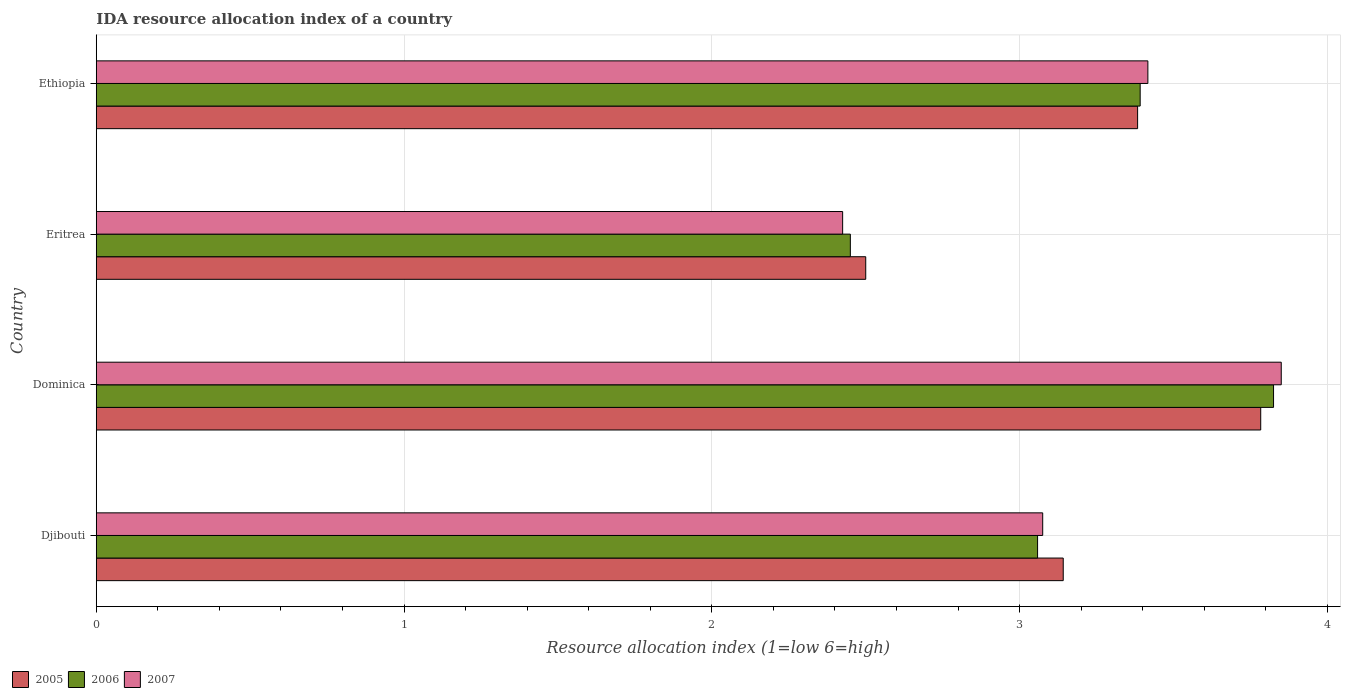Are the number of bars per tick equal to the number of legend labels?
Provide a short and direct response. Yes. How many bars are there on the 3rd tick from the bottom?
Your answer should be compact. 3. What is the label of the 2nd group of bars from the top?
Make the answer very short. Eritrea. In how many cases, is the number of bars for a given country not equal to the number of legend labels?
Provide a succinct answer. 0. What is the IDA resource allocation index in 2006 in Djibouti?
Provide a short and direct response. 3.06. Across all countries, what is the maximum IDA resource allocation index in 2007?
Offer a very short reply. 3.85. Across all countries, what is the minimum IDA resource allocation index in 2007?
Make the answer very short. 2.42. In which country was the IDA resource allocation index in 2007 maximum?
Ensure brevity in your answer.  Dominica. In which country was the IDA resource allocation index in 2006 minimum?
Make the answer very short. Eritrea. What is the total IDA resource allocation index in 2006 in the graph?
Provide a succinct answer. 12.73. What is the difference between the IDA resource allocation index in 2005 in Djibouti and that in Ethiopia?
Offer a very short reply. -0.24. What is the difference between the IDA resource allocation index in 2005 in Dominica and the IDA resource allocation index in 2007 in Ethiopia?
Keep it short and to the point. 0.37. What is the average IDA resource allocation index in 2005 per country?
Ensure brevity in your answer.  3.2. What is the difference between the IDA resource allocation index in 2007 and IDA resource allocation index in 2006 in Djibouti?
Offer a terse response. 0.02. In how many countries, is the IDA resource allocation index in 2005 greater than 0.6000000000000001 ?
Keep it short and to the point. 4. What is the ratio of the IDA resource allocation index in 2006 in Eritrea to that in Ethiopia?
Offer a very short reply. 0.72. Is the IDA resource allocation index in 2007 in Djibouti less than that in Dominica?
Ensure brevity in your answer.  Yes. Is the difference between the IDA resource allocation index in 2007 in Dominica and Ethiopia greater than the difference between the IDA resource allocation index in 2006 in Dominica and Ethiopia?
Your response must be concise. No. What is the difference between the highest and the second highest IDA resource allocation index in 2007?
Give a very brief answer. 0.43. What is the difference between the highest and the lowest IDA resource allocation index in 2007?
Ensure brevity in your answer.  1.43. Is the sum of the IDA resource allocation index in 2007 in Eritrea and Ethiopia greater than the maximum IDA resource allocation index in 2005 across all countries?
Give a very brief answer. Yes. What is the difference between two consecutive major ticks on the X-axis?
Make the answer very short. 1. Does the graph contain any zero values?
Offer a very short reply. No. What is the title of the graph?
Your answer should be compact. IDA resource allocation index of a country. What is the label or title of the X-axis?
Your response must be concise. Resource allocation index (1=low 6=high). What is the Resource allocation index (1=low 6=high) of 2005 in Djibouti?
Make the answer very short. 3.14. What is the Resource allocation index (1=low 6=high) in 2006 in Djibouti?
Your response must be concise. 3.06. What is the Resource allocation index (1=low 6=high) in 2007 in Djibouti?
Give a very brief answer. 3.08. What is the Resource allocation index (1=low 6=high) in 2005 in Dominica?
Offer a terse response. 3.78. What is the Resource allocation index (1=low 6=high) in 2006 in Dominica?
Your answer should be very brief. 3.83. What is the Resource allocation index (1=low 6=high) in 2007 in Dominica?
Ensure brevity in your answer.  3.85. What is the Resource allocation index (1=low 6=high) of 2005 in Eritrea?
Give a very brief answer. 2.5. What is the Resource allocation index (1=low 6=high) in 2006 in Eritrea?
Provide a short and direct response. 2.45. What is the Resource allocation index (1=low 6=high) in 2007 in Eritrea?
Your answer should be compact. 2.42. What is the Resource allocation index (1=low 6=high) of 2005 in Ethiopia?
Offer a terse response. 3.38. What is the Resource allocation index (1=low 6=high) in 2006 in Ethiopia?
Provide a short and direct response. 3.39. What is the Resource allocation index (1=low 6=high) in 2007 in Ethiopia?
Provide a succinct answer. 3.42. Across all countries, what is the maximum Resource allocation index (1=low 6=high) of 2005?
Your answer should be compact. 3.78. Across all countries, what is the maximum Resource allocation index (1=low 6=high) in 2006?
Your answer should be compact. 3.83. Across all countries, what is the maximum Resource allocation index (1=low 6=high) of 2007?
Your answer should be very brief. 3.85. Across all countries, what is the minimum Resource allocation index (1=low 6=high) of 2006?
Your answer should be very brief. 2.45. Across all countries, what is the minimum Resource allocation index (1=low 6=high) of 2007?
Your answer should be compact. 2.42. What is the total Resource allocation index (1=low 6=high) in 2005 in the graph?
Your response must be concise. 12.81. What is the total Resource allocation index (1=low 6=high) of 2006 in the graph?
Give a very brief answer. 12.72. What is the total Resource allocation index (1=low 6=high) of 2007 in the graph?
Offer a very short reply. 12.77. What is the difference between the Resource allocation index (1=low 6=high) of 2005 in Djibouti and that in Dominica?
Your response must be concise. -0.64. What is the difference between the Resource allocation index (1=low 6=high) of 2006 in Djibouti and that in Dominica?
Your response must be concise. -0.77. What is the difference between the Resource allocation index (1=low 6=high) of 2007 in Djibouti and that in Dominica?
Your answer should be compact. -0.78. What is the difference between the Resource allocation index (1=low 6=high) of 2005 in Djibouti and that in Eritrea?
Keep it short and to the point. 0.64. What is the difference between the Resource allocation index (1=low 6=high) in 2006 in Djibouti and that in Eritrea?
Ensure brevity in your answer.  0.61. What is the difference between the Resource allocation index (1=low 6=high) of 2007 in Djibouti and that in Eritrea?
Offer a terse response. 0.65. What is the difference between the Resource allocation index (1=low 6=high) of 2005 in Djibouti and that in Ethiopia?
Your response must be concise. -0.24. What is the difference between the Resource allocation index (1=low 6=high) of 2006 in Djibouti and that in Ethiopia?
Provide a short and direct response. -0.33. What is the difference between the Resource allocation index (1=low 6=high) of 2007 in Djibouti and that in Ethiopia?
Offer a terse response. -0.34. What is the difference between the Resource allocation index (1=low 6=high) in 2005 in Dominica and that in Eritrea?
Give a very brief answer. 1.28. What is the difference between the Resource allocation index (1=low 6=high) of 2006 in Dominica and that in Eritrea?
Keep it short and to the point. 1.38. What is the difference between the Resource allocation index (1=low 6=high) of 2007 in Dominica and that in Eritrea?
Your answer should be compact. 1.43. What is the difference between the Resource allocation index (1=low 6=high) of 2005 in Dominica and that in Ethiopia?
Provide a succinct answer. 0.4. What is the difference between the Resource allocation index (1=low 6=high) in 2006 in Dominica and that in Ethiopia?
Provide a short and direct response. 0.43. What is the difference between the Resource allocation index (1=low 6=high) of 2007 in Dominica and that in Ethiopia?
Provide a succinct answer. 0.43. What is the difference between the Resource allocation index (1=low 6=high) of 2005 in Eritrea and that in Ethiopia?
Provide a succinct answer. -0.88. What is the difference between the Resource allocation index (1=low 6=high) in 2006 in Eritrea and that in Ethiopia?
Your response must be concise. -0.94. What is the difference between the Resource allocation index (1=low 6=high) in 2007 in Eritrea and that in Ethiopia?
Give a very brief answer. -0.99. What is the difference between the Resource allocation index (1=low 6=high) in 2005 in Djibouti and the Resource allocation index (1=low 6=high) in 2006 in Dominica?
Give a very brief answer. -0.68. What is the difference between the Resource allocation index (1=low 6=high) in 2005 in Djibouti and the Resource allocation index (1=low 6=high) in 2007 in Dominica?
Provide a succinct answer. -0.71. What is the difference between the Resource allocation index (1=low 6=high) in 2006 in Djibouti and the Resource allocation index (1=low 6=high) in 2007 in Dominica?
Offer a very short reply. -0.79. What is the difference between the Resource allocation index (1=low 6=high) in 2005 in Djibouti and the Resource allocation index (1=low 6=high) in 2006 in Eritrea?
Make the answer very short. 0.69. What is the difference between the Resource allocation index (1=low 6=high) of 2005 in Djibouti and the Resource allocation index (1=low 6=high) of 2007 in Eritrea?
Provide a short and direct response. 0.72. What is the difference between the Resource allocation index (1=low 6=high) in 2006 in Djibouti and the Resource allocation index (1=low 6=high) in 2007 in Eritrea?
Provide a short and direct response. 0.63. What is the difference between the Resource allocation index (1=low 6=high) in 2005 in Djibouti and the Resource allocation index (1=low 6=high) in 2007 in Ethiopia?
Provide a short and direct response. -0.28. What is the difference between the Resource allocation index (1=low 6=high) in 2006 in Djibouti and the Resource allocation index (1=low 6=high) in 2007 in Ethiopia?
Provide a short and direct response. -0.36. What is the difference between the Resource allocation index (1=low 6=high) in 2005 in Dominica and the Resource allocation index (1=low 6=high) in 2007 in Eritrea?
Ensure brevity in your answer.  1.36. What is the difference between the Resource allocation index (1=low 6=high) in 2005 in Dominica and the Resource allocation index (1=low 6=high) in 2006 in Ethiopia?
Give a very brief answer. 0.39. What is the difference between the Resource allocation index (1=low 6=high) in 2005 in Dominica and the Resource allocation index (1=low 6=high) in 2007 in Ethiopia?
Keep it short and to the point. 0.37. What is the difference between the Resource allocation index (1=low 6=high) in 2006 in Dominica and the Resource allocation index (1=low 6=high) in 2007 in Ethiopia?
Make the answer very short. 0.41. What is the difference between the Resource allocation index (1=low 6=high) in 2005 in Eritrea and the Resource allocation index (1=low 6=high) in 2006 in Ethiopia?
Provide a short and direct response. -0.89. What is the difference between the Resource allocation index (1=low 6=high) in 2005 in Eritrea and the Resource allocation index (1=low 6=high) in 2007 in Ethiopia?
Give a very brief answer. -0.92. What is the difference between the Resource allocation index (1=low 6=high) of 2006 in Eritrea and the Resource allocation index (1=low 6=high) of 2007 in Ethiopia?
Ensure brevity in your answer.  -0.97. What is the average Resource allocation index (1=low 6=high) of 2005 per country?
Your response must be concise. 3.2. What is the average Resource allocation index (1=low 6=high) of 2006 per country?
Your response must be concise. 3.18. What is the average Resource allocation index (1=low 6=high) in 2007 per country?
Your answer should be compact. 3.19. What is the difference between the Resource allocation index (1=low 6=high) in 2005 and Resource allocation index (1=low 6=high) in 2006 in Djibouti?
Give a very brief answer. 0.08. What is the difference between the Resource allocation index (1=low 6=high) in 2005 and Resource allocation index (1=low 6=high) in 2007 in Djibouti?
Offer a terse response. 0.07. What is the difference between the Resource allocation index (1=low 6=high) in 2006 and Resource allocation index (1=low 6=high) in 2007 in Djibouti?
Offer a terse response. -0.02. What is the difference between the Resource allocation index (1=low 6=high) of 2005 and Resource allocation index (1=low 6=high) of 2006 in Dominica?
Make the answer very short. -0.04. What is the difference between the Resource allocation index (1=low 6=high) of 2005 and Resource allocation index (1=low 6=high) of 2007 in Dominica?
Make the answer very short. -0.07. What is the difference between the Resource allocation index (1=low 6=high) of 2006 and Resource allocation index (1=low 6=high) of 2007 in Dominica?
Provide a succinct answer. -0.03. What is the difference between the Resource allocation index (1=low 6=high) in 2005 and Resource allocation index (1=low 6=high) in 2007 in Eritrea?
Ensure brevity in your answer.  0.07. What is the difference between the Resource allocation index (1=low 6=high) in 2006 and Resource allocation index (1=low 6=high) in 2007 in Eritrea?
Give a very brief answer. 0.03. What is the difference between the Resource allocation index (1=low 6=high) in 2005 and Resource allocation index (1=low 6=high) in 2006 in Ethiopia?
Make the answer very short. -0.01. What is the difference between the Resource allocation index (1=low 6=high) in 2005 and Resource allocation index (1=low 6=high) in 2007 in Ethiopia?
Your answer should be very brief. -0.03. What is the difference between the Resource allocation index (1=low 6=high) in 2006 and Resource allocation index (1=low 6=high) in 2007 in Ethiopia?
Your response must be concise. -0.03. What is the ratio of the Resource allocation index (1=low 6=high) in 2005 in Djibouti to that in Dominica?
Your response must be concise. 0.83. What is the ratio of the Resource allocation index (1=low 6=high) in 2006 in Djibouti to that in Dominica?
Provide a succinct answer. 0.8. What is the ratio of the Resource allocation index (1=low 6=high) of 2007 in Djibouti to that in Dominica?
Keep it short and to the point. 0.8. What is the ratio of the Resource allocation index (1=low 6=high) in 2005 in Djibouti to that in Eritrea?
Your response must be concise. 1.26. What is the ratio of the Resource allocation index (1=low 6=high) in 2006 in Djibouti to that in Eritrea?
Your answer should be very brief. 1.25. What is the ratio of the Resource allocation index (1=low 6=high) of 2007 in Djibouti to that in Eritrea?
Offer a very short reply. 1.27. What is the ratio of the Resource allocation index (1=low 6=high) in 2006 in Djibouti to that in Ethiopia?
Offer a very short reply. 0.9. What is the ratio of the Resource allocation index (1=low 6=high) in 2007 in Djibouti to that in Ethiopia?
Provide a succinct answer. 0.9. What is the ratio of the Resource allocation index (1=low 6=high) of 2005 in Dominica to that in Eritrea?
Give a very brief answer. 1.51. What is the ratio of the Resource allocation index (1=low 6=high) in 2006 in Dominica to that in Eritrea?
Your answer should be compact. 1.56. What is the ratio of the Resource allocation index (1=low 6=high) in 2007 in Dominica to that in Eritrea?
Keep it short and to the point. 1.59. What is the ratio of the Resource allocation index (1=low 6=high) of 2005 in Dominica to that in Ethiopia?
Offer a terse response. 1.12. What is the ratio of the Resource allocation index (1=low 6=high) in 2006 in Dominica to that in Ethiopia?
Ensure brevity in your answer.  1.13. What is the ratio of the Resource allocation index (1=low 6=high) in 2007 in Dominica to that in Ethiopia?
Your response must be concise. 1.13. What is the ratio of the Resource allocation index (1=low 6=high) in 2005 in Eritrea to that in Ethiopia?
Keep it short and to the point. 0.74. What is the ratio of the Resource allocation index (1=low 6=high) of 2006 in Eritrea to that in Ethiopia?
Provide a succinct answer. 0.72. What is the ratio of the Resource allocation index (1=low 6=high) in 2007 in Eritrea to that in Ethiopia?
Give a very brief answer. 0.71. What is the difference between the highest and the second highest Resource allocation index (1=low 6=high) in 2005?
Your response must be concise. 0.4. What is the difference between the highest and the second highest Resource allocation index (1=low 6=high) in 2006?
Provide a succinct answer. 0.43. What is the difference between the highest and the second highest Resource allocation index (1=low 6=high) of 2007?
Give a very brief answer. 0.43. What is the difference between the highest and the lowest Resource allocation index (1=low 6=high) in 2005?
Keep it short and to the point. 1.28. What is the difference between the highest and the lowest Resource allocation index (1=low 6=high) in 2006?
Provide a succinct answer. 1.38. What is the difference between the highest and the lowest Resource allocation index (1=low 6=high) of 2007?
Offer a terse response. 1.43. 